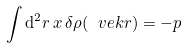Convert formula to latex. <formula><loc_0><loc_0><loc_500><loc_500>\int { \mathrm d } ^ { 2 } r \, x \, \delta \rho ( { \ v e k r } ) = - p</formula> 